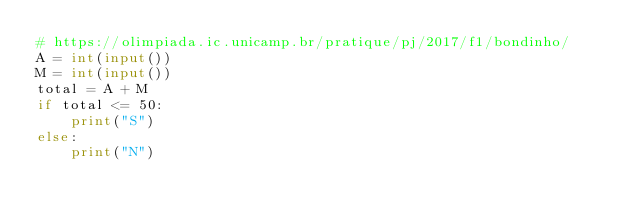Convert code to text. <code><loc_0><loc_0><loc_500><loc_500><_Python_># https://olimpiada.ic.unicamp.br/pratique/pj/2017/f1/bondinho/
A = int(input())
M = int(input())
total = A + M
if total <= 50:
    print("S")
else:
    print("N")</code> 